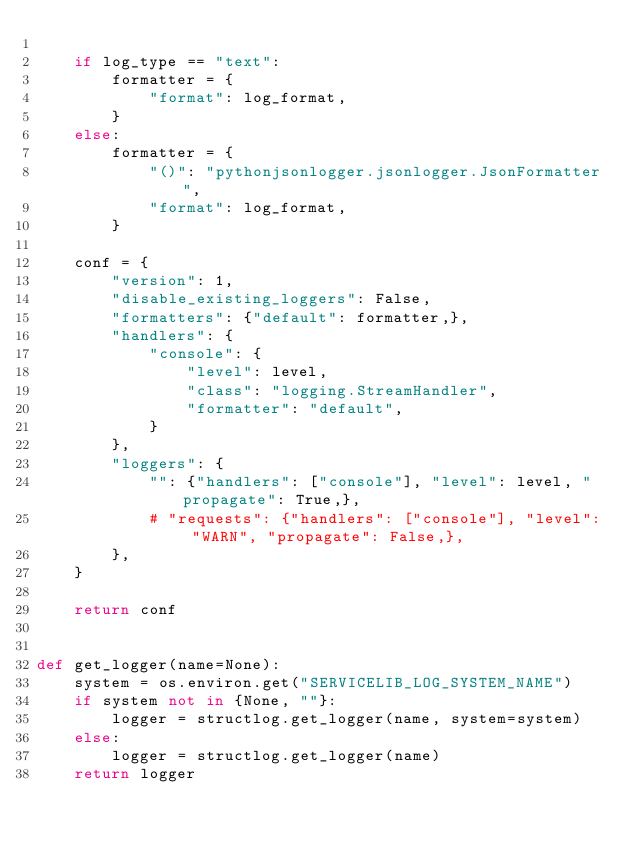<code> <loc_0><loc_0><loc_500><loc_500><_Python_>
    if log_type == "text":
        formatter = {
            "format": log_format,
        }
    else:
        formatter = {
            "()": "pythonjsonlogger.jsonlogger.JsonFormatter",
            "format": log_format,
        }

    conf = {
        "version": 1,
        "disable_existing_loggers": False,
        "formatters": {"default": formatter,},
        "handlers": {
            "console": {
                "level": level,
                "class": "logging.StreamHandler",
                "formatter": "default",
            }
        },
        "loggers": {
            "": {"handlers": ["console"], "level": level, "propagate": True,},
            # "requests": {"handlers": ["console"], "level": "WARN", "propagate": False,},
        },
    }

    return conf


def get_logger(name=None):
    system = os.environ.get("SERVICELIB_LOG_SYSTEM_NAME")
    if system not in {None, ""}:
        logger = structlog.get_logger(name, system=system)
    else:
        logger = structlog.get_logger(name)
    return logger
</code> 